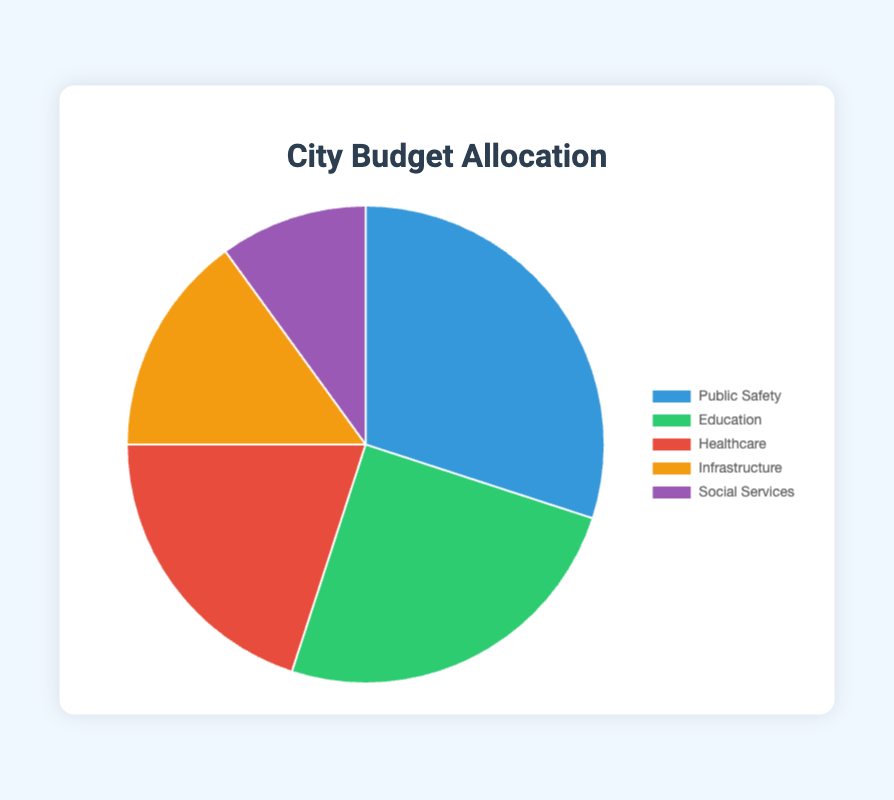How much more of the budget is allocated to Public Safety compared to Social Services? The allocation for Public Safety is 30% and for Social Services is 10%. The difference is 30% - 10% = 20%.
Answer: 20% Which department receives the second highest allocation? The departments are ranked by allocation percentages: Public Safety (30%), Education (25%), Healthcare (20%), Infrastructure (15%), and Social Services (10%). So, Education receives the second highest allocation.
Answer: Education What is the total percentage allocation for Education and Healthcare combined? The allocation for Education is 25% and for Healthcare is 20%. The combined allocation is 25% + 20% = 45%.
Answer: 45% Which department has the smallest allocation, and what is the percentage? The smallest allocation in the chart is for Social Services at 10%.
Answer: Social Services, 10% Compare the allocations for Infrastructure and Social Services. How much more is Infrastructure allocated? Infrastructure is allocated 15% and Social Services 10%. The difference is 15% - 10% = 5%.
Answer: 5% What proportion of the budget goes to non-public safety related departments? The allocation for non-public safety departments (Education, Healthcare, Infrastructure, Social Services) is 25% + 20% + 15% + 10% = 70%.
Answer: 70% If Infrastructure received an additional 5% from Healthcare, what would be the new percentages for both departments? Originally, Infrastructure is allocated 15% and Healthcare 20%. If 5% shifts from Healthcare to Infrastructure, Infrastructure becomes 15% + 5% = 20% and Healthcare becomes 20% - 5% = 15%.
Answer: Infrastructure: 20%, Healthcare: 15% Which department’s allocation is visually represented by the green segment in the chart? The chart’s green segment represents the Education department with a 25% allocation.
Answer: Education How many departments have an allocation of 20% or greater? From the data: Public Safety (30%), Education (25%), Healthcare (20%). There are three departments with 20% or greater allocation.
Answer: 3 Compare the combined allocation of Public Safety and Education against the combined allocation of Healthcare, Infrastructure, and Social Services. Which is larger and by how much? Public Safety and Education combined have 30% + 25% = 55%. Healthcare, Infrastructure, and Social Services combined have 20% + 15% + 10% = 45%. The difference is 55% - 45% = 10%.
Answer: Public Safety and Education, 10% 